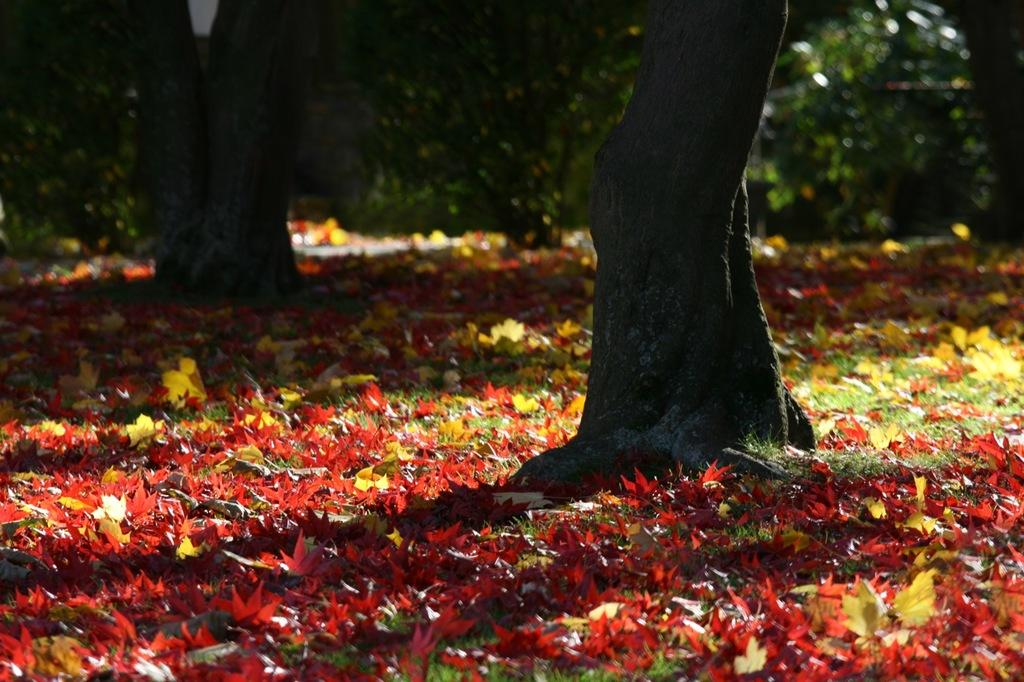What type of vegetation can be seen in the image? There are trees in the image. What is present on the ground in the image? There are leaves on the grass at the bottom of the image. What type of clothing can be seen hanging on the trees in the image? There is no clothing present in the image; it only features trees and leaves on the grass. 